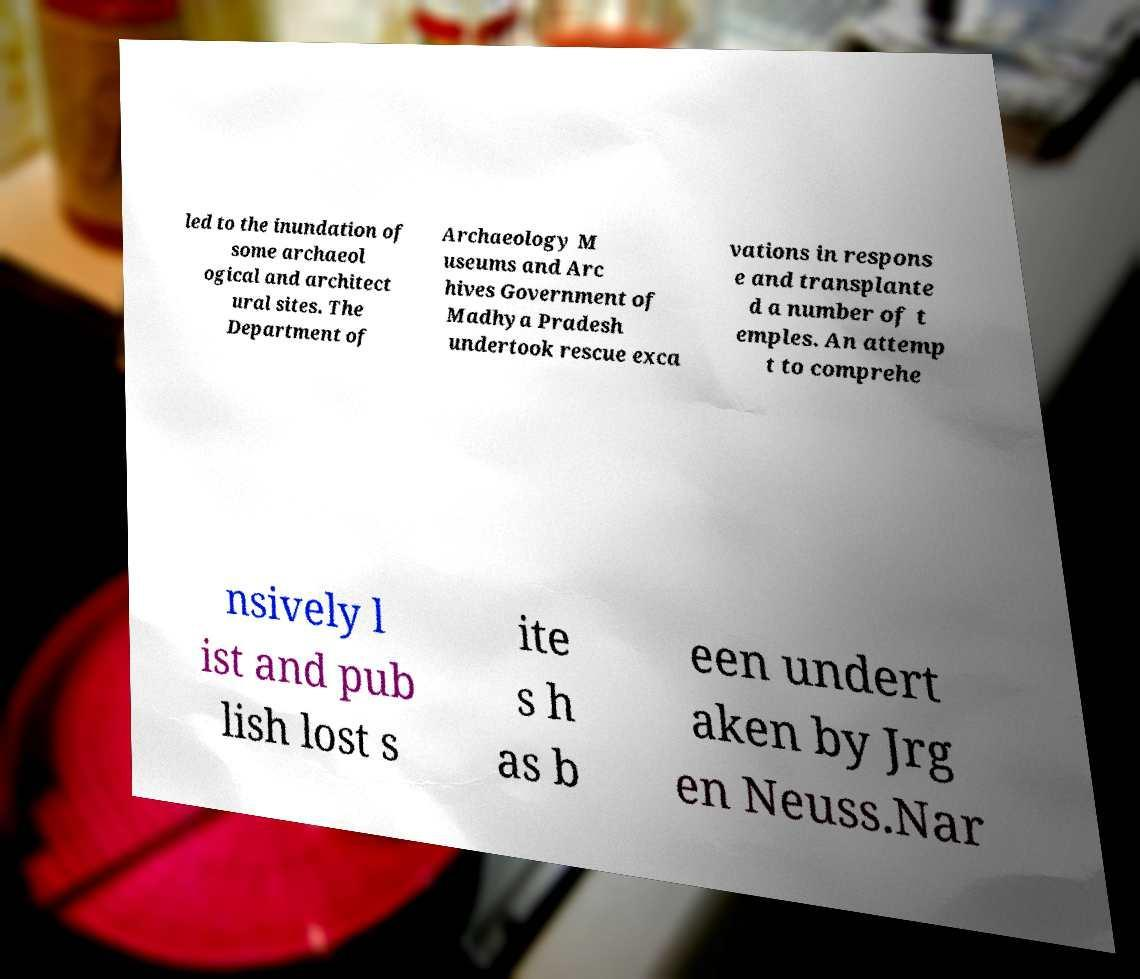Please identify and transcribe the text found in this image. led to the inundation of some archaeol ogical and architect ural sites. The Department of Archaeology M useums and Arc hives Government of Madhya Pradesh undertook rescue exca vations in respons e and transplante d a number of t emples. An attemp t to comprehe nsively l ist and pub lish lost s ite s h as b een undert aken by Jrg en Neuss.Nar 